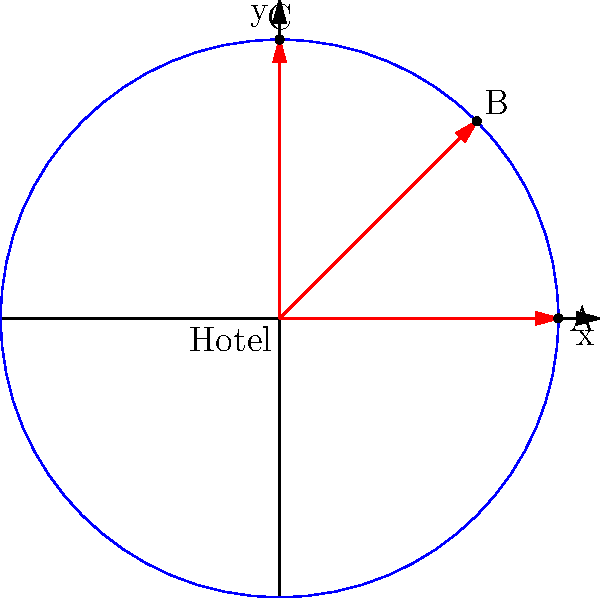A celebrity needs to escape from the hotel quickly. Three secret exits are available, represented by points A, B, and C on the polar coordinate system, where the hotel is at the origin. Exit A is at $(5,0)$, B at $(5,\frac{\pi}{4})$, and C at $(5,\frac{\pi}{2})$. If the paparazzi are known to congregate near the x-axis, which exit should the celebrity use for the quickest escape? To determine the quickest escape route, we need to consider the position of the exits relative to the paparazzi's location:

1. Exit A: Located at $(5,0)$ in polar coordinates, which translates to $(5,0)$ in Cartesian coordinates. This is directly on the x-axis where the paparazzi are known to gather.

2. Exit B: Located at $(5,\frac{\pi}{4})$ in polar coordinates. In Cartesian coordinates, this is:
   $x = 5\cos(\frac{\pi}{4}) \approx 3.54$
   $y = 5\sin(\frac{\pi}{4}) \approx 3.54$
   This exit is elevated above the x-axis but still relatively close to the paparazzi.

3. Exit C: Located at $(5,\frac{\pi}{2})$ in polar coordinates, which translates to $(0,5)$ in Cartesian coordinates. This exit is directly along the y-axis, furthest from the x-axis where the paparazzi are located.

Given that the paparazzi are near the x-axis, the exit furthest from this axis would provide the quickest and safest escape route. Therefore, Exit C is the best choice as it's the farthest from the x-axis and the paparazzi's known location.
Answer: Exit C $(5,\frac{\pi}{2})$ 